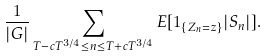Convert formula to latex. <formula><loc_0><loc_0><loc_500><loc_500>\frac { 1 } { | G | } \sum _ { T - c T ^ { 3 / 4 } \leq n \leq T + c T ^ { 3 / 4 } } E [ 1 _ { \{ Z _ { n } = z \} } | S _ { n } | ] .</formula> 